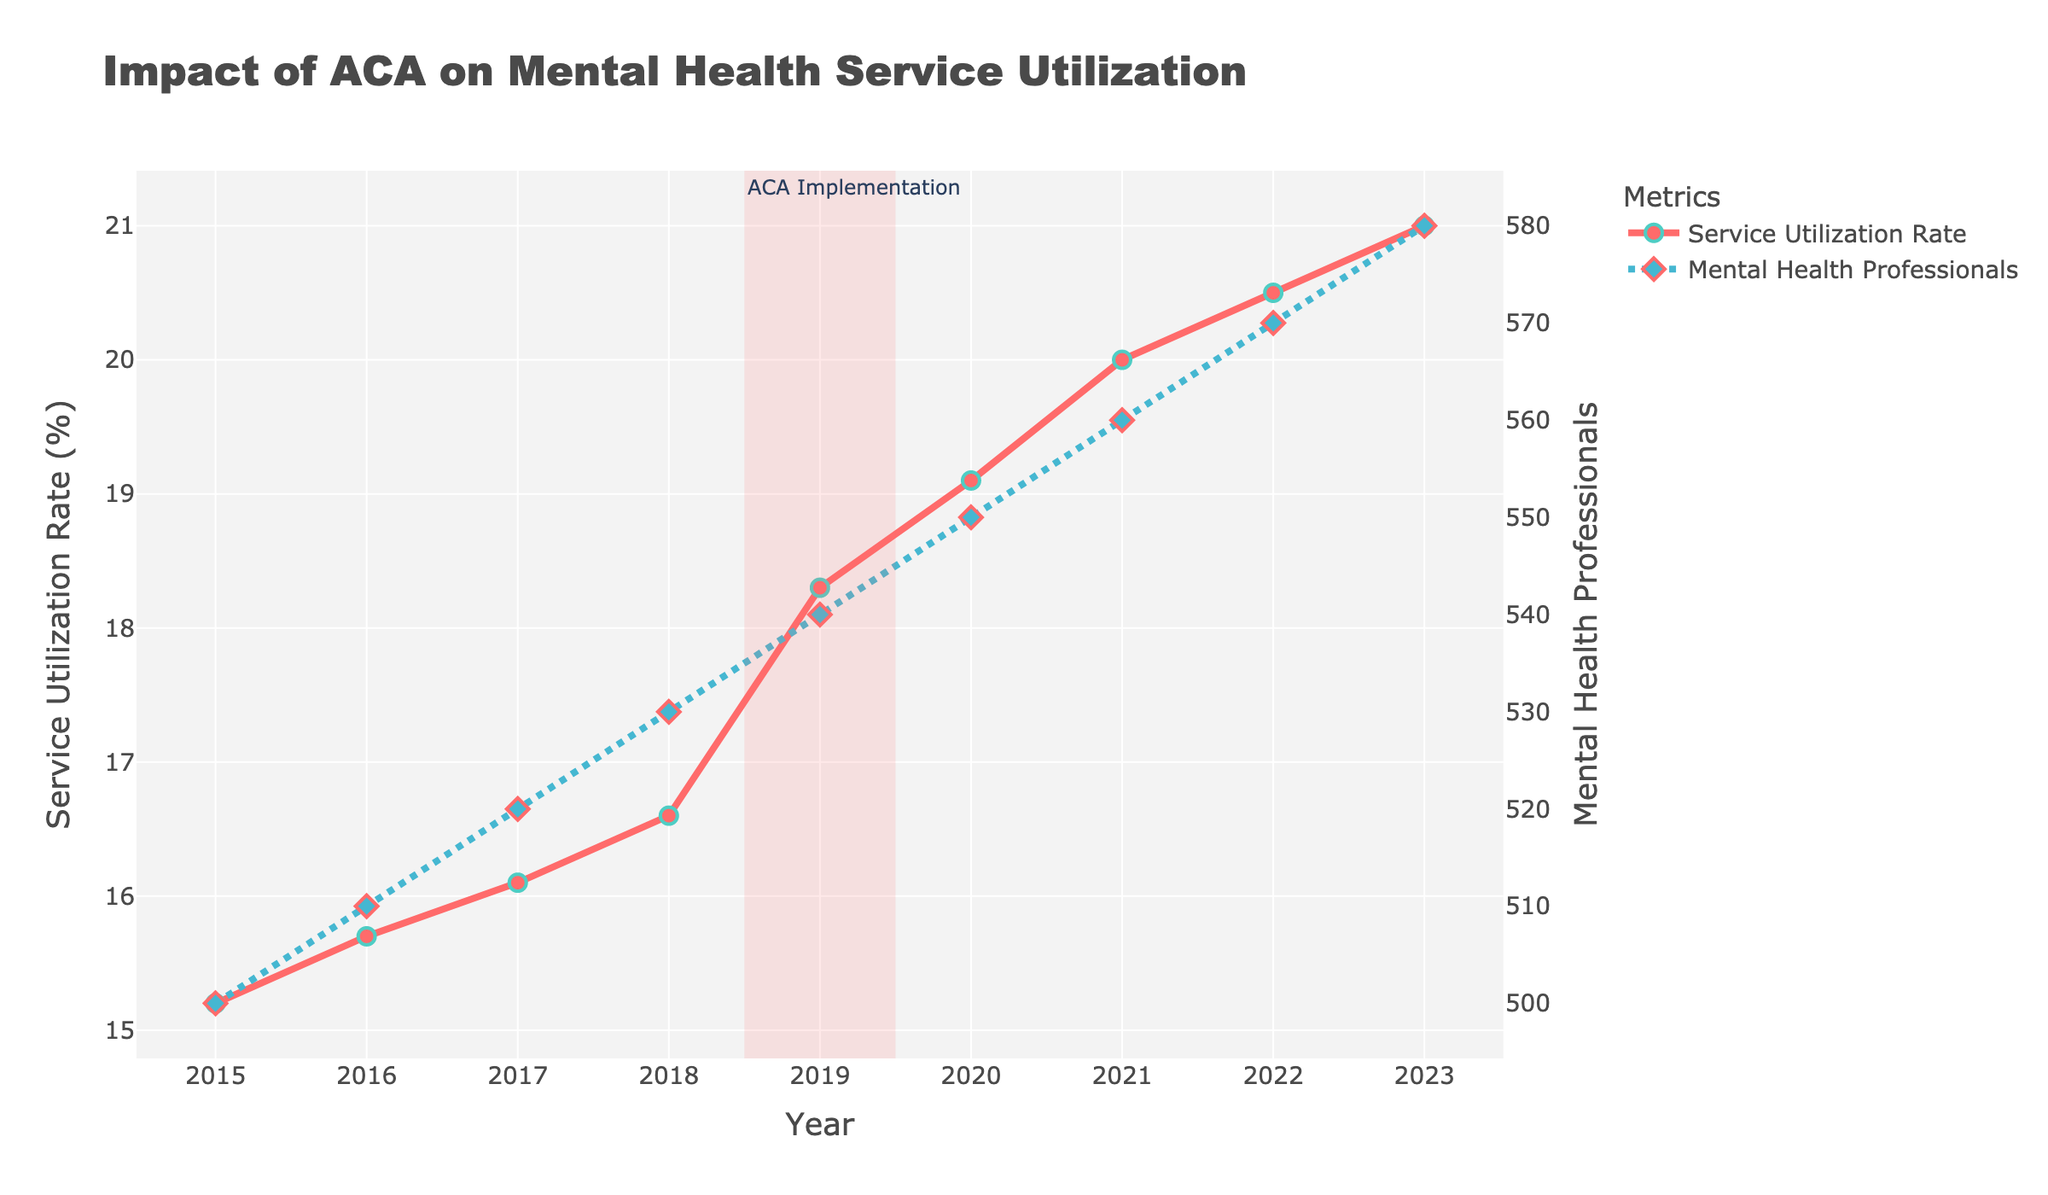What's the title of the figure? The title is typically located at the top of the figure, providing a summary of the overall content or topic. In this case, it's "Impact of ACA on Mental Health Service Utilization."
Answer: Impact of ACA on Mental Health Service Utilization How many distinct years are represented in the figure? To determine the number of distinct years, count the unique data points along the x-axis labeled "Year" from 2015 to 2023.
Answer: 9 Which policy period shows a higher service utilization rate overall, Pre-ACA or Post-ACA? By comparing the "Service Utilization Rate" from 2015 to 2018 (Pre-ACA) and 2019 to 2023 (Post-ACA), we observe that the rates increase significantly starting in 2019.
Answer: Post-ACA What color is used to represent the "Service Utilization Rate" in the figure? The "Service Utilization Rate" line and markers in the figure are depicted using a specific color in the plot's legend and visualization.
Answer: Red In 2021, how many mental health professionals were recorded, and what was the service utilization rate? Locate the year 2021 on the x-axis, then find the corresponding values from the two y-axes (mental health professionals on the right and service utilization rate on the left).
Answer: 560 mental health professionals, 20.0% service utilization rate What’s the difference in the service utilization rate between 2019 and 2023? Subtract the service utilization rate in 2019 from the rate in 2023. In 2019, it was 18.3%, and in 2023, it was 21.0%.
Answer: 2.7% How many mental health professionals were there in 2019, and how did that number change by 2023? Check the figure for the number of mental health professionals in 2019 (540) and then in 2023 (580), and calculate the difference.
Answer: Increased by 40 What annotation is used to mark the change in healthcare policy, and where is it located? The annotation indicating the ACA implementation is represented by a highlighted vertical region around 2019, labeled "ACA Implementation" at the top left of that region.
Answer: ACA Implementation, around 2019 Did the service utilization rate ever decrease from one year to the next? Observe the trend of the service utilization rate from year to year to identify if there's any downward movement.
Answer: No What trend is observed for the number of mental health professionals from 2015 to 2023? The figure shows a consistently rising trend in the number of mental health professionals each year from 2015 to 2023.
Answer: Increasing trend 